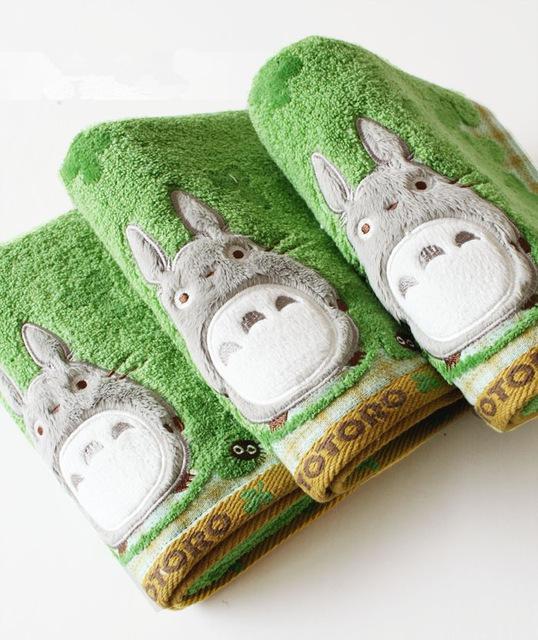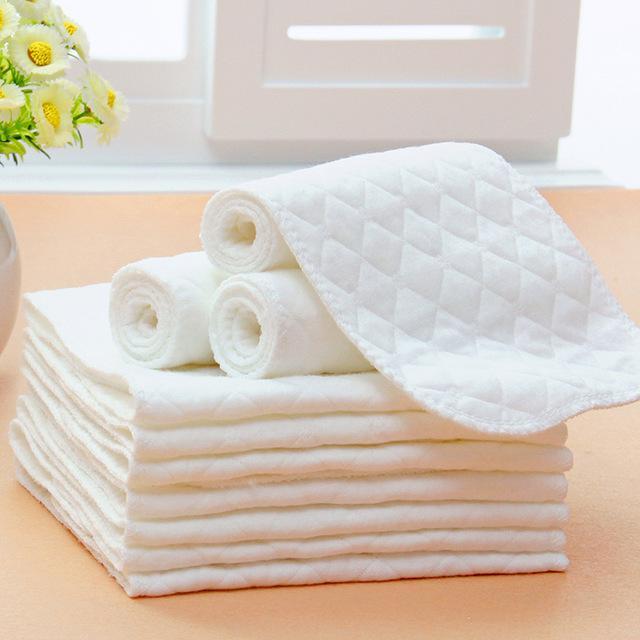The first image is the image on the left, the second image is the image on the right. Examine the images to the left and right. Is the description "All towels shown are solid colored, and at least one image shows a vertical stack of four different colored folded towels." accurate? Answer yes or no. No. 